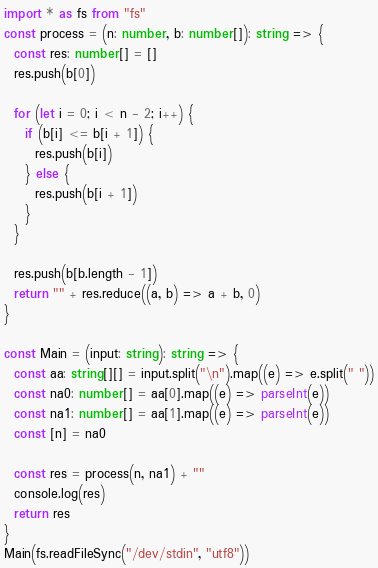Convert code to text. <code><loc_0><loc_0><loc_500><loc_500><_TypeScript_>import * as fs from "fs"
const process = (n: number, b: number[]): string => {
  const res: number[] = []
  res.push(b[0])

  for (let i = 0; i < n - 2; i++) {
    if (b[i] <= b[i + 1]) {
      res.push(b[i])
    } else {
      res.push(b[i + 1])
    }
  }

  res.push(b[b.length - 1])
  return "" + res.reduce((a, b) => a + b, 0)
}

const Main = (input: string): string => {
  const aa: string[][] = input.split("\n").map((e) => e.split(" "))
  const na0: number[] = aa[0].map((e) => parseInt(e))
  const na1: number[] = aa[1].map((e) => parseInt(e))
  const [n] = na0

  const res = process(n, na1) + ""
  console.log(res)
  return res
}
Main(fs.readFileSync("/dev/stdin", "utf8"))
</code> 